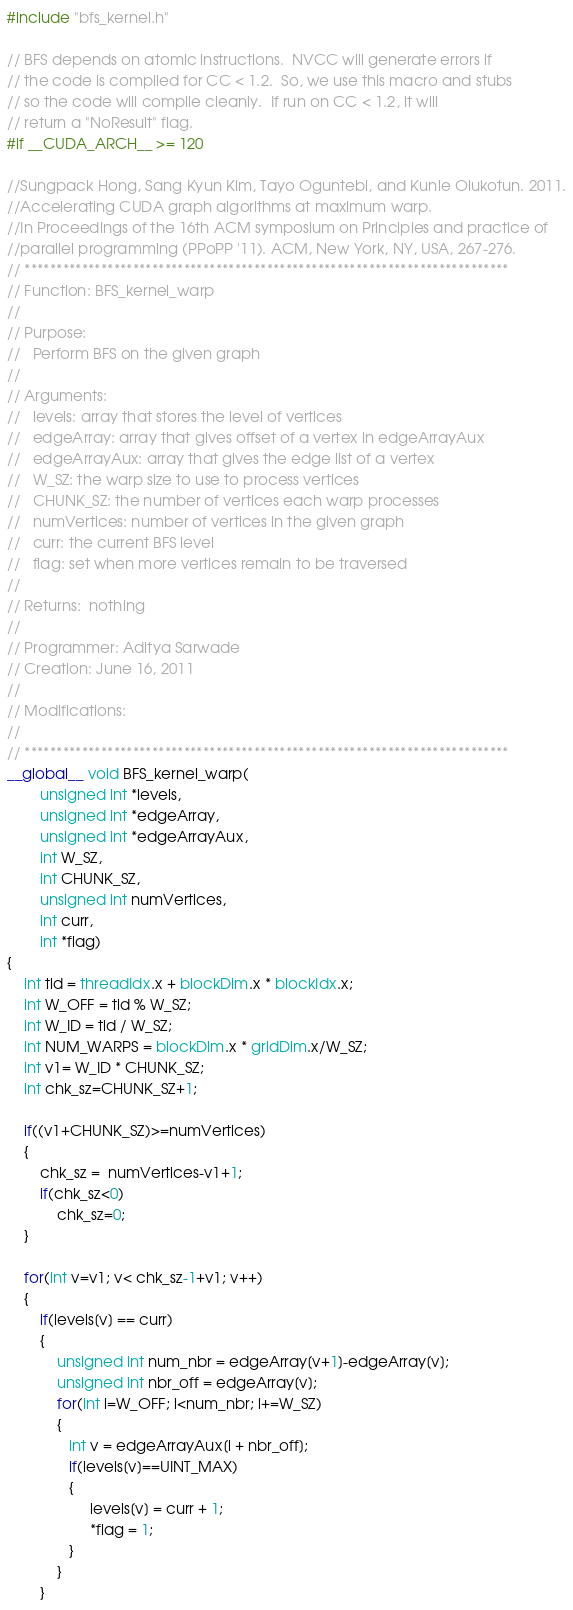<code> <loc_0><loc_0><loc_500><loc_500><_Cuda_>#include "bfs_kernel.h"

// BFS depends on atomic instructions.  NVCC will generate errors if
// the code is compiled for CC < 1.2.  So, we use this macro and stubs
// so the code will compile cleanly.  If run on CC < 1.2, it will
// return a "NoResult" flag.
#if __CUDA_ARCH__ >= 120

//Sungpack Hong, Sang Kyun Kim, Tayo Oguntebi, and Kunle Olukotun. 2011.
//Accelerating CUDA graph algorithms at maximum warp.
//In Proceedings of the 16th ACM symposium on Principles and practice of
//parallel programming (PPoPP '11). ACM, New York, NY, USA, 267-276.
// ****************************************************************************
// Function: BFS_kernel_warp
//
// Purpose:
//   Perform BFS on the given graph
//
// Arguments:
//   levels: array that stores the level of vertices
//   edgeArray: array that gives offset of a vertex in edgeArrayAux
//   edgeArrayAux: array that gives the edge list of a vertex
//   W_SZ: the warp size to use to process vertices
//   CHUNK_SZ: the number of vertices each warp processes
//   numVertices: number of vertices in the given graph
//   curr: the current BFS level
//   flag: set when more vertices remain to be traversed
//
// Returns:  nothing
//
// Programmer: Aditya Sarwade
// Creation: June 16, 2011
//
// Modifications:
//
// ****************************************************************************
__global__ void BFS_kernel_warp(
        unsigned int *levels,
        unsigned int *edgeArray,
        unsigned int *edgeArrayAux,
        int W_SZ,
        int CHUNK_SZ,
        unsigned int numVertices,
        int curr,
        int *flag)
{
    int tid = threadIdx.x + blockDim.x * blockIdx.x;
    int W_OFF = tid % W_SZ;
    int W_ID = tid / W_SZ;
    int NUM_WARPS = blockDim.x * gridDim.x/W_SZ;
    int v1= W_ID * CHUNK_SZ;
    int chk_sz=CHUNK_SZ+1;

    if((v1+CHUNK_SZ)>=numVertices)
    {
        chk_sz =  numVertices-v1+1;
        if(chk_sz<0)
            chk_sz=0;
    }

    for(int v=v1; v< chk_sz-1+v1; v++)
    {
        if(levels[v] == curr)
        {
            unsigned int num_nbr = edgeArray[v+1]-edgeArray[v];
            unsigned int nbr_off = edgeArray[v];
            for(int i=W_OFF; i<num_nbr; i+=W_SZ)
            {
               int v = edgeArrayAux[i + nbr_off];
               if(levels[v]==UINT_MAX)
               {
                    levels[v] = curr + 1;
                    *flag = 1;
               }
            }
        }</code> 